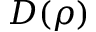<formula> <loc_0><loc_0><loc_500><loc_500>D ( \rho )</formula> 